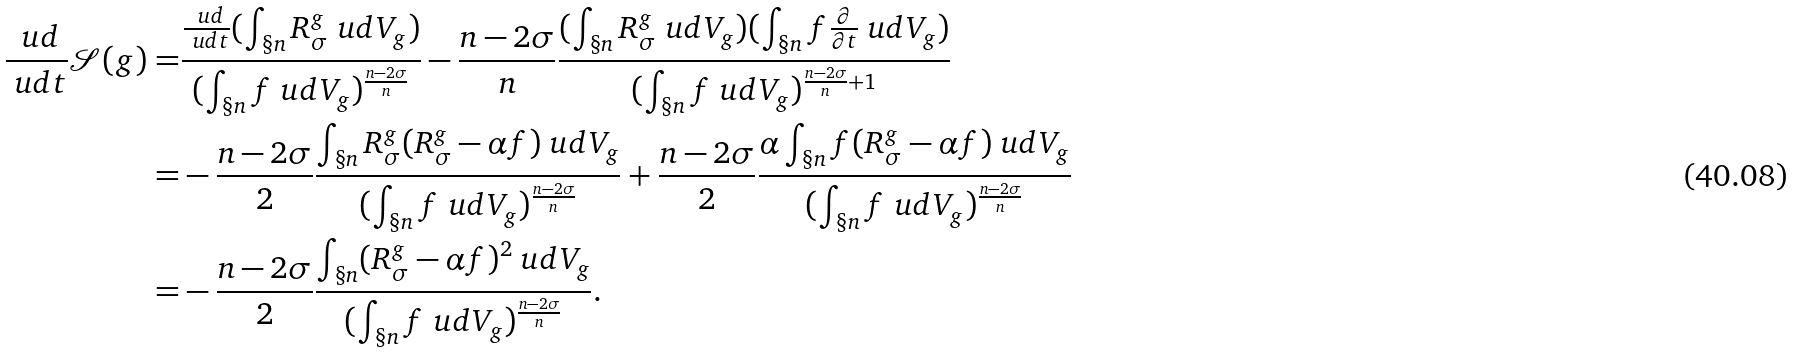<formula> <loc_0><loc_0><loc_500><loc_500>\frac { \ u d } { \ u d t } \mathcal { S } ( g ) = & \frac { \frac { \ u d } { \ u d t } ( \int _ { \S n } R _ { \sigma } ^ { g } \ u d V _ { g } ) } { ( \int _ { \S n } f \ u d V _ { g } ) ^ { \frac { n - 2 \sigma } { n } } } - \frac { n - 2 \sigma } { n } \frac { ( \int _ { \S n } R _ { \sigma } ^ { g } \ u d V _ { g } ) ( \int _ { \S n } f \frac { \partial } { \partial t } \ u d V _ { g } ) } { ( \int _ { \S n } f \ u d V _ { g } ) ^ { \frac { n - 2 \sigma } { n } + 1 } } \\ = & - \frac { n - 2 \sigma } { 2 } \frac { \int _ { \S n } R _ { \sigma } ^ { g } ( R _ { \sigma } ^ { g } - \alpha f ) \ u d V _ { g } } { ( \int _ { \S n } f \ u d V _ { g } ) ^ { \frac { n - 2 \sigma } { n } } } + \frac { n - 2 \sigma } { 2 } \frac { \alpha \int _ { \S n } f ( R _ { \sigma } ^ { g } - \alpha f ) \ u d V _ { g } } { ( \int _ { \S n } f \ u d V _ { g } ) ^ { \frac { n - 2 \sigma } { n } } } \\ = & - \frac { n - 2 \sigma } { 2 } \frac { \int _ { \S n } ( R _ { \sigma } ^ { g } - \alpha f ) ^ { 2 } \ u d V _ { g } } { ( \int _ { \S n } f \ u d V _ { g } ) ^ { \frac { n - 2 \sigma } { n } } } .</formula> 